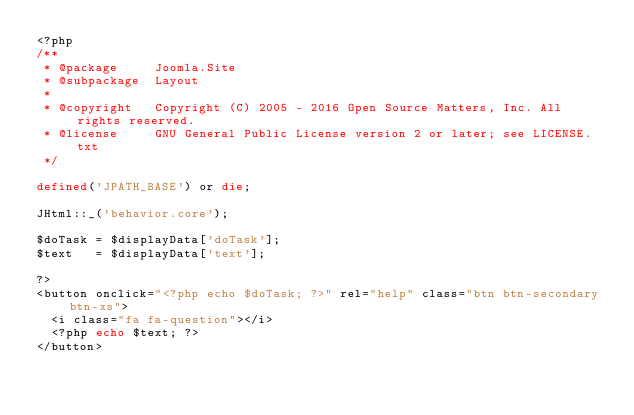Convert code to text. <code><loc_0><loc_0><loc_500><loc_500><_PHP_><?php
/**
 * @package     Joomla.Site
 * @subpackage  Layout
 *
 * @copyright   Copyright (C) 2005 - 2016 Open Source Matters, Inc. All rights reserved.
 * @license     GNU General Public License version 2 or later; see LICENSE.txt
 */

defined('JPATH_BASE') or die;

JHtml::_('behavior.core');

$doTask = $displayData['doTask'];
$text   = $displayData['text'];

?>
<button onclick="<?php echo $doTask; ?>" rel="help" class="btn btn-secondary btn-xs">
	<i class="fa fa-question"></i>
	<?php echo $text; ?>
</button>
</code> 